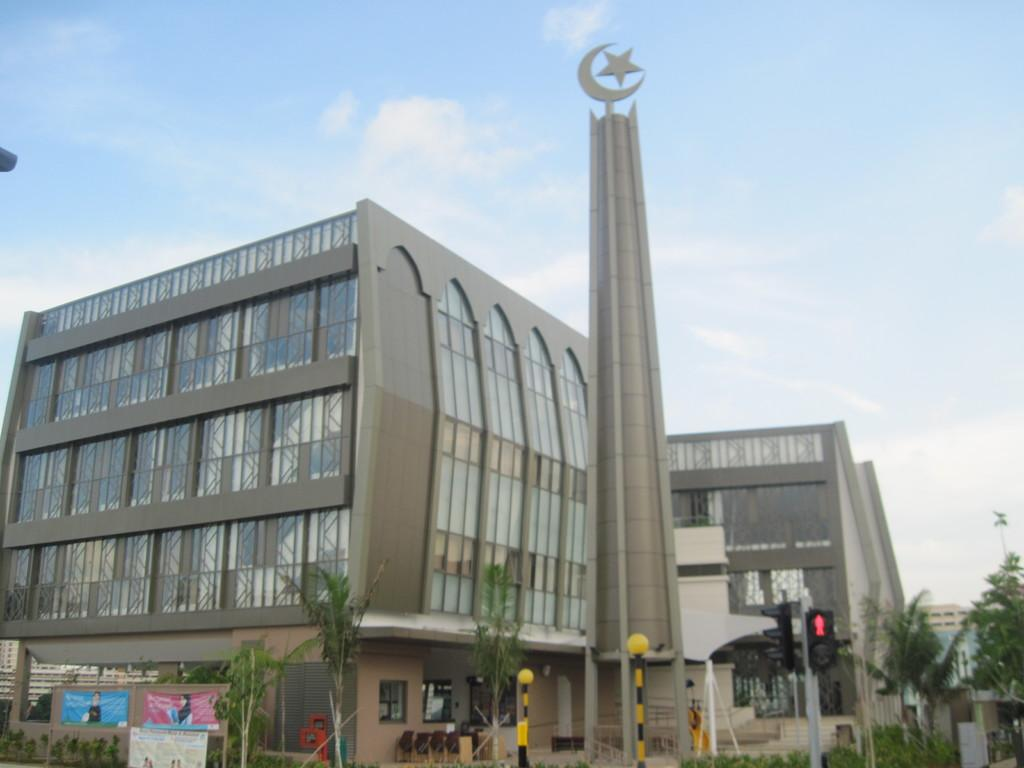What type of structures can be seen in the image? There are buildings in the image. What else can be seen in the image besides buildings? There are poles, trees, banners, traffic signals, and sky visible in the image. Can you describe the sky in the image? The sky is visible in the image, and there are clouds present. What might be used for guiding traffic in the image? Traffic signals are present in the image for guiding traffic. What type of nerve can be seen in the image? There is no nerve present in the image; it features buildings, poles, trees, banners, traffic signals, and sky. Can you describe the zephyr in the image? There is no zephyr present in the image; it is a term used to describe a gentle breeze, and there is no mention of wind or breeze in the provided facts. 